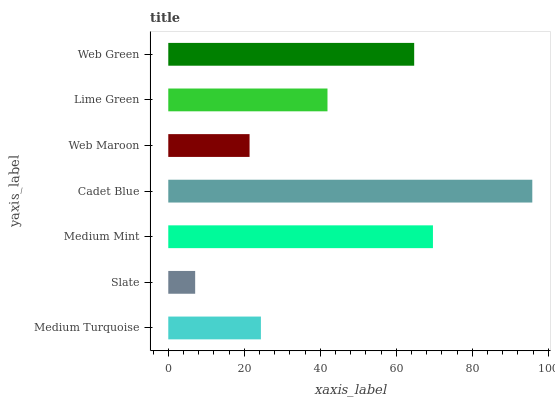Is Slate the minimum?
Answer yes or no. Yes. Is Cadet Blue the maximum?
Answer yes or no. Yes. Is Medium Mint the minimum?
Answer yes or no. No. Is Medium Mint the maximum?
Answer yes or no. No. Is Medium Mint greater than Slate?
Answer yes or no. Yes. Is Slate less than Medium Mint?
Answer yes or no. Yes. Is Slate greater than Medium Mint?
Answer yes or no. No. Is Medium Mint less than Slate?
Answer yes or no. No. Is Lime Green the high median?
Answer yes or no. Yes. Is Lime Green the low median?
Answer yes or no. Yes. Is Cadet Blue the high median?
Answer yes or no. No. Is Slate the low median?
Answer yes or no. No. 